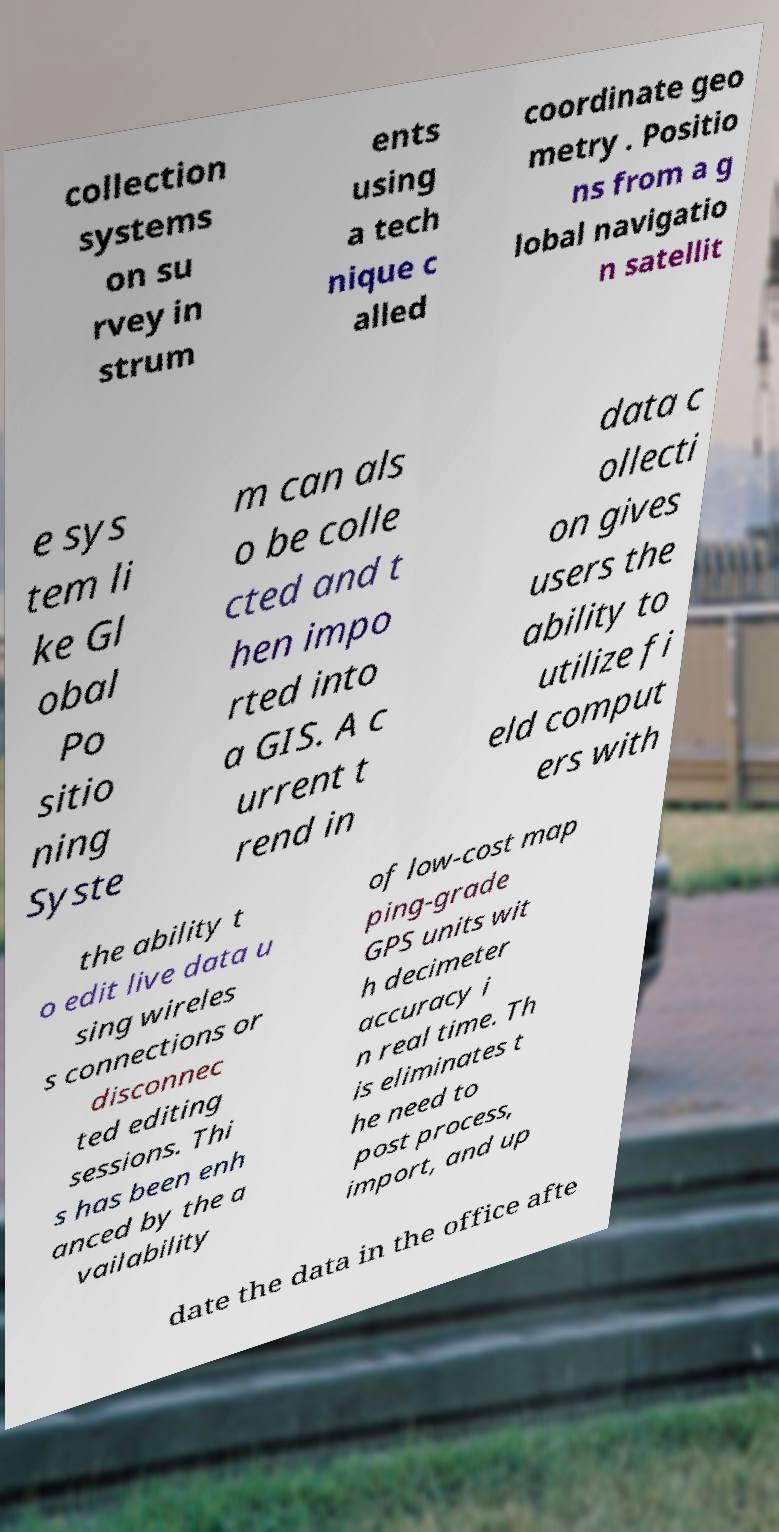For documentation purposes, I need the text within this image transcribed. Could you provide that? collection systems on su rvey in strum ents using a tech nique c alled coordinate geo metry . Positio ns from a g lobal navigatio n satellit e sys tem li ke Gl obal Po sitio ning Syste m can als o be colle cted and t hen impo rted into a GIS. A c urrent t rend in data c ollecti on gives users the ability to utilize fi eld comput ers with the ability t o edit live data u sing wireles s connections or disconnec ted editing sessions. Thi s has been enh anced by the a vailability of low-cost map ping-grade GPS units wit h decimeter accuracy i n real time. Th is eliminates t he need to post process, import, and up date the data in the office afte 